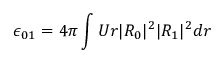<formula> <loc_0><loc_0><loc_500><loc_500>\epsilon _ { 0 1 } = 4 \pi \int U r | R _ { 0 } | ^ { 2 } | R _ { 1 } | ^ { 2 } d r</formula> 